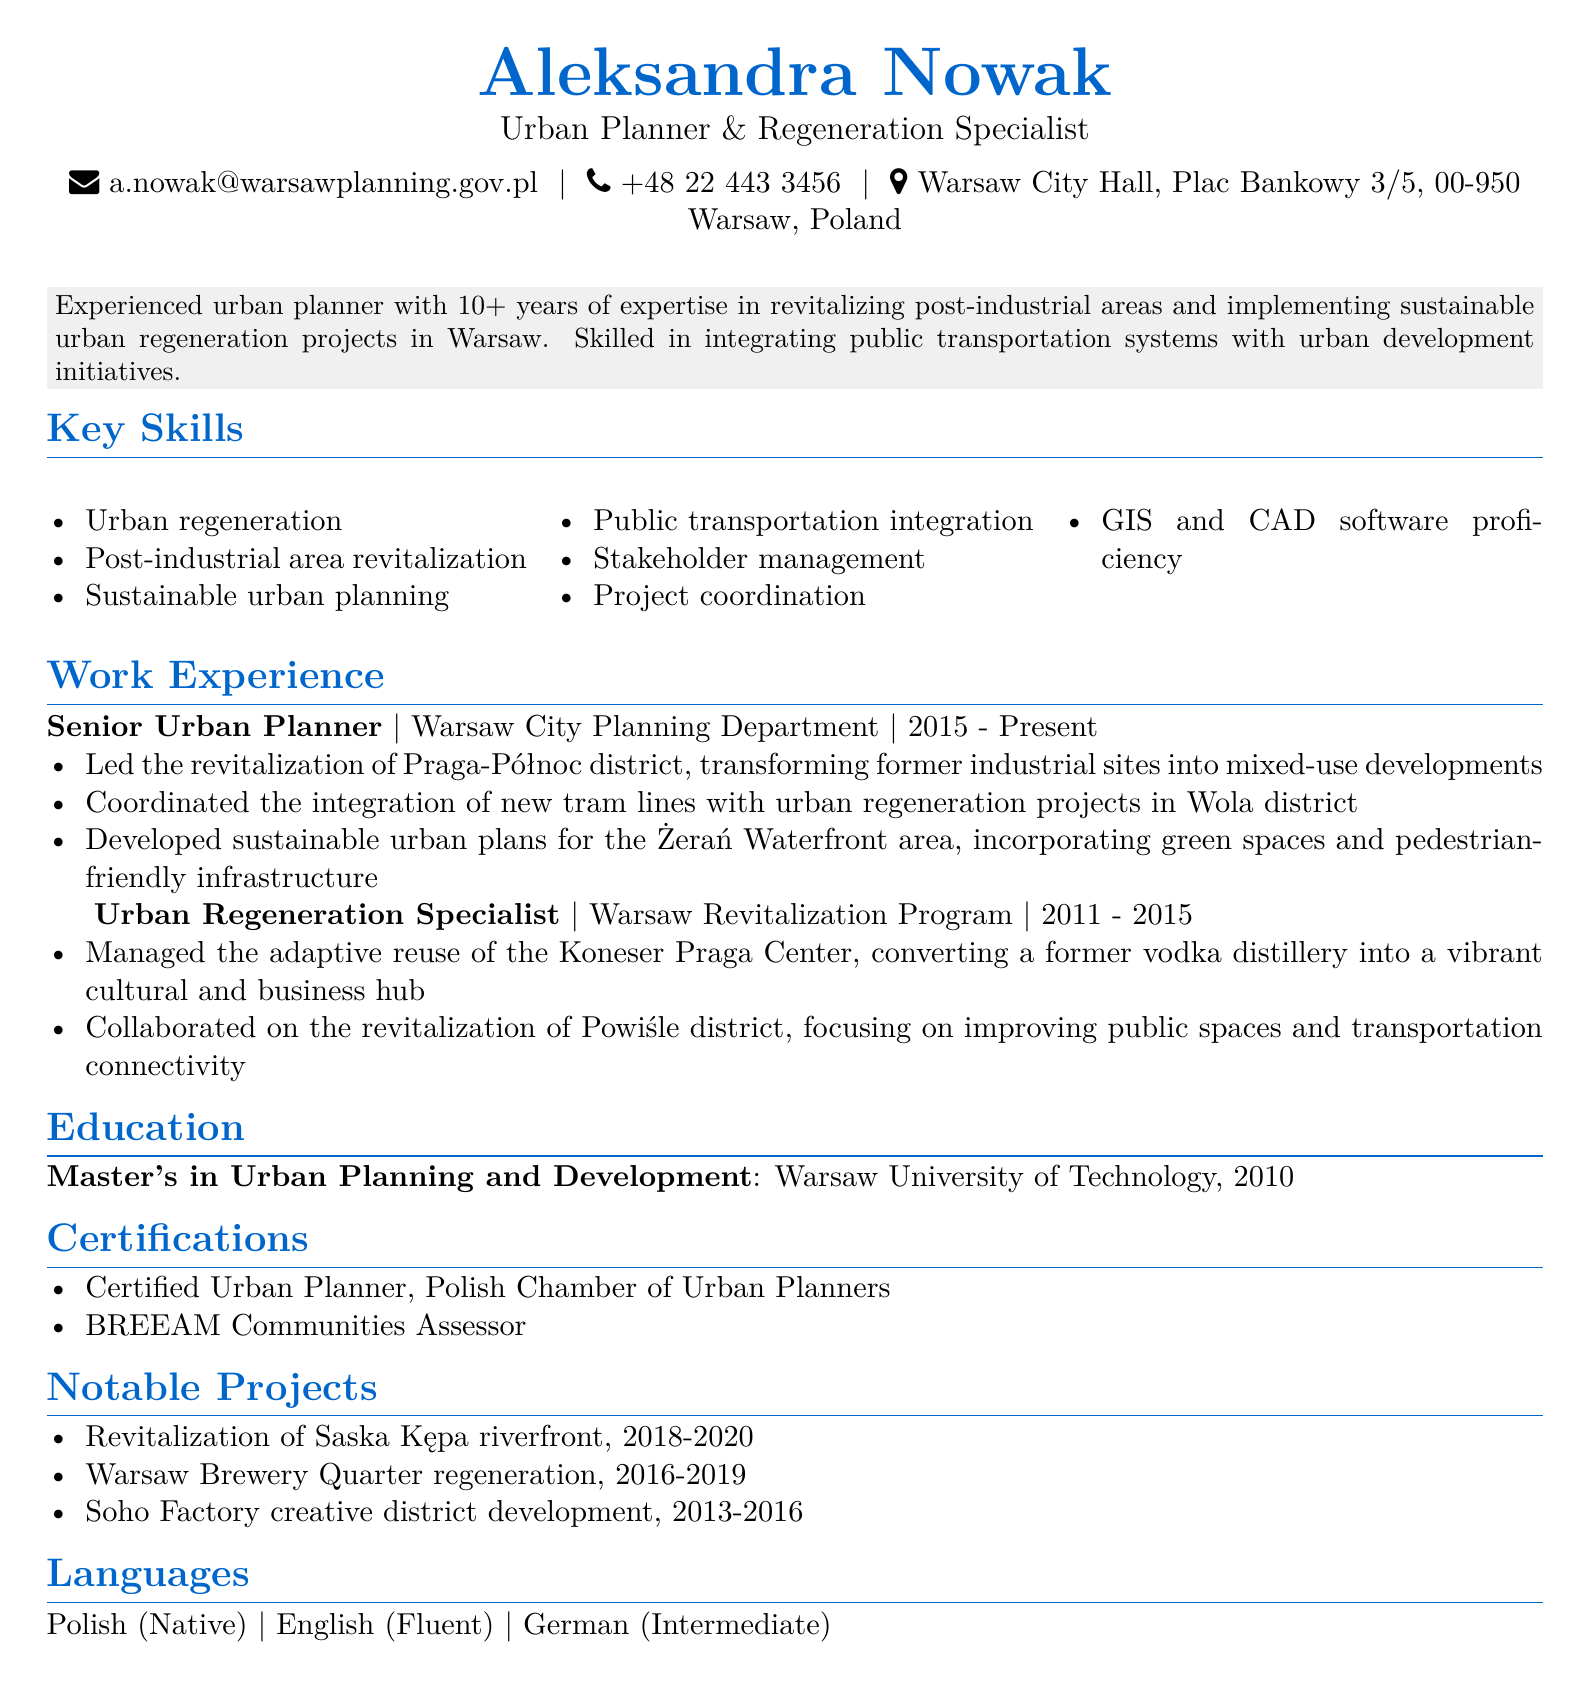What is the name of the urban planner? The document states the name of the urban planner at the top section.
Answer: Aleksandra Nowak What is Aleksandra Nowak's title? The title of Aleksandra Nowak is mentioned just below her name.
Answer: Urban Planner & Regeneration Specialist How many years of experience does she have? The professional summary section indicates her experience level.
Answer: 10+ What major project did she work on in the Powiśle district? The specific responsibility for the Powiśle district is given in the work experience section.
Answer: Improving public spaces and transportation connectivity Where did Aleksandra obtain her degree? The education section specifies the institution where she studied.
Answer: Warsaw University of Technology Which certification does she hold related to BREEAM? The certifications section directly states the certification she has.
Answer: BREEAM Communities Assessor What language does she speak at an intermediate level? The languages section indicates her proficiency levels in various languages.
Answer: German During which years did she serve as an Urban Regeneration Specialist? The work experience section clearly lists her duration in this role.
Answer: 2011 - 2015 What notable project took place from 2018 to 2020? The notable projects section lists various projects with their timelines.
Answer: Revitalization of Saska Kępa riverfront 